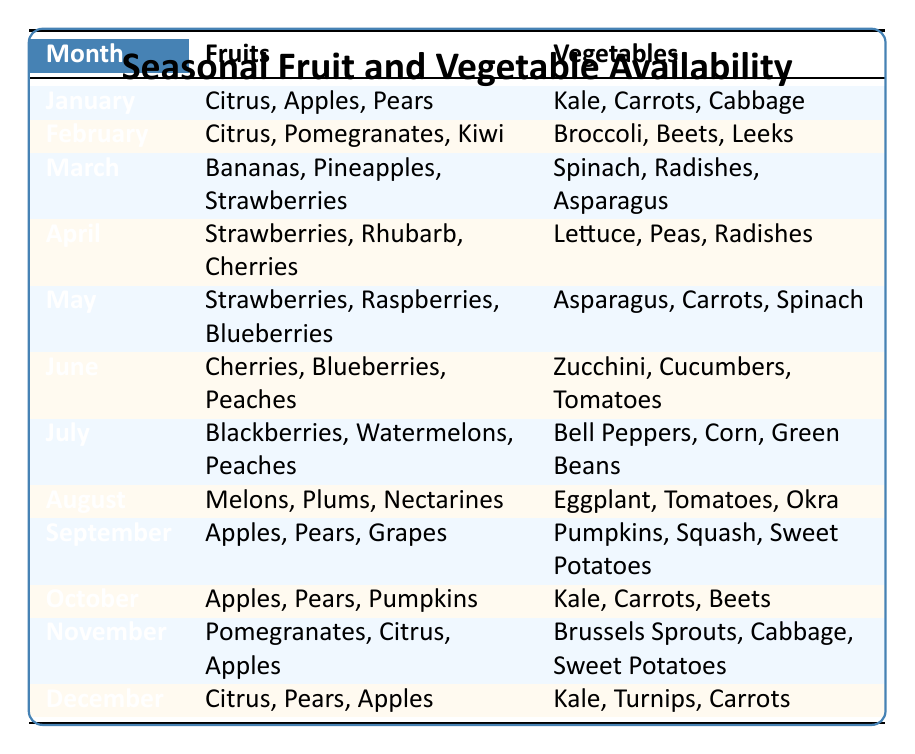What fruits are available in June? In June, the table shows the fruits listed are Cherries, Blueberries, and Peaches.
Answer: Cherries, Blueberries, Peaches Which vegetables are available in November? The vegetables listed for November in the table are Brussels Sprouts, Cabbage, and Sweet Potatoes.
Answer: Brussels Sprouts, Cabbage, Sweet Potatoes Are there any months where Apples are available? By reviewing the table, Apples are available in January, September, October, and November.
Answer: Yes How many types of fruits are available in May? In May, there are three types of fruits available: Strawberries, Raspberries, and Blueberries.
Answer: 3 In which month do we see the most variety of vegetables available? Analyzing the vegetables listed, we find that every month has three types; therefore, there is an equal variety in all months, which is three types.
Answer: Three types in all months Which fruit appears in the highest number of months? Upon inspecting the table, Apples appear in January, September, October, and November, totaling four months, making them the most frequent fruit.
Answer: Apples appear in four months What is the difference in the number of vegetable types available in January and July? January has three types of vegetables (Kale, Carrots, Cabbage) and July has three types (Bell Peppers, Corn, Green Beans). The difference in the number of vegetable types is 0, as both months have the same count.
Answer: 0 Is there any month without Peas in the vegetable list? Upon checking the table, Peas appear only in April; therefore, all other months do not have Peas listed in their vegetable availability.
Answer: Yes Which two months have the same fruits available? Looking closely at the table, both October and November feature Apples and Citrus; however, only October also includes Pumpkins, making it unique. Therefore, no two months share the exact same fruits available.
Answer: No two months share the same fruits 